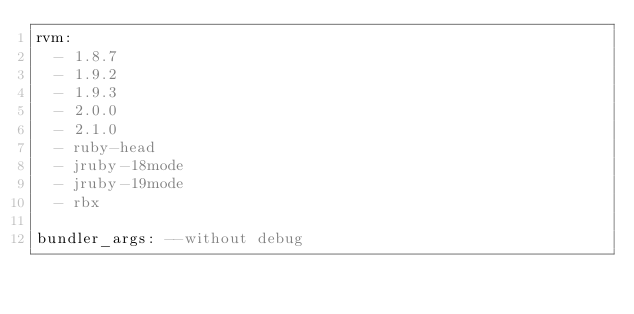<code> <loc_0><loc_0><loc_500><loc_500><_YAML_>rvm:
  - 1.8.7
  - 1.9.2
  - 1.9.3
  - 2.0.0
  - 2.1.0
  - ruby-head
  - jruby-18mode
  - jruby-19mode
  - rbx

bundler_args: --without debug
</code> 